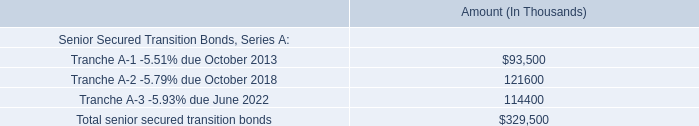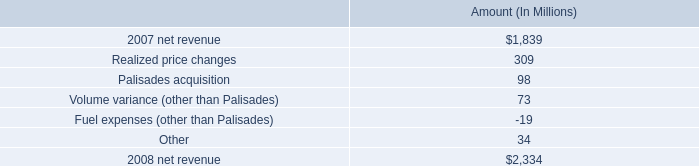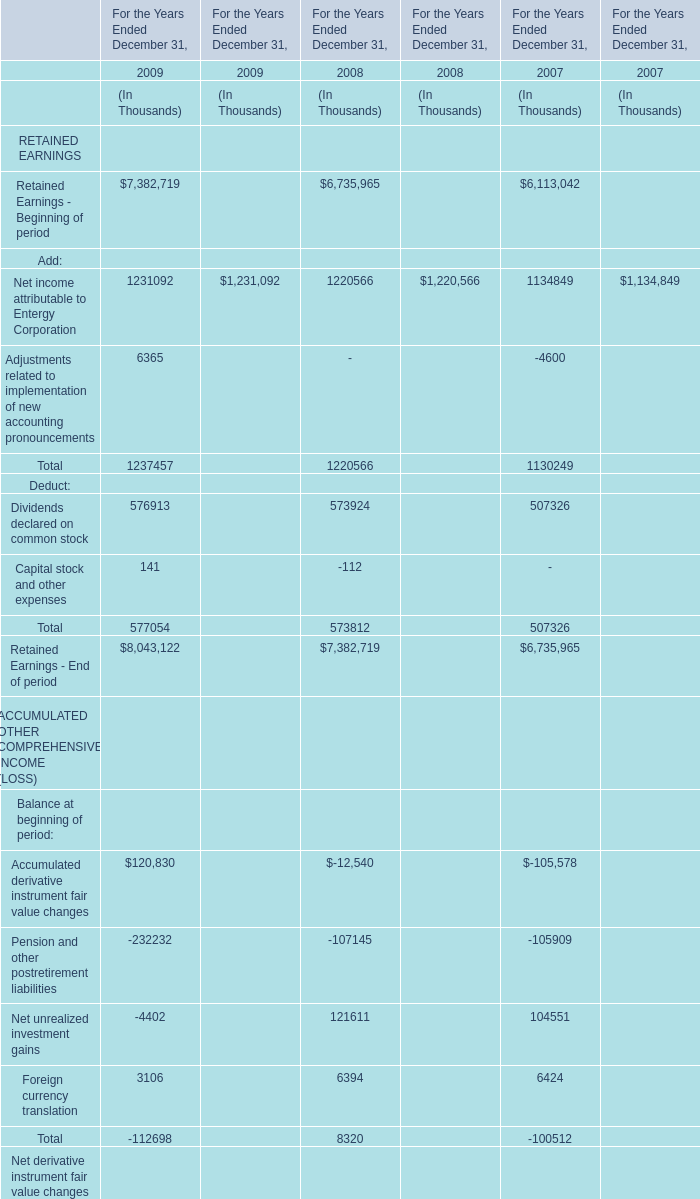Which year is For the Years Ended December 31, the least? 
Answer: 2007. 